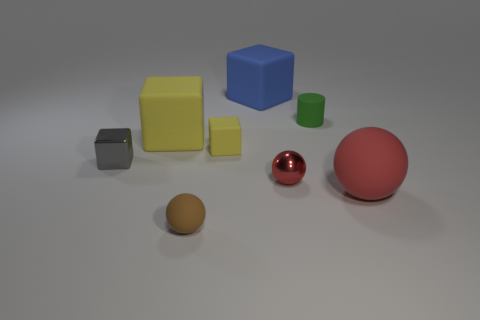Subtract 1 spheres. How many spheres are left? 2 Subtract all gray blocks. How many blocks are left? 3 Subtract all small gray cubes. How many cubes are left? 3 Subtract all cyan blocks. Subtract all red spheres. How many blocks are left? 4 Add 2 blue blocks. How many objects exist? 10 Subtract all cylinders. How many objects are left? 7 Add 3 small matte balls. How many small matte balls are left? 4 Add 2 small red shiny objects. How many small red shiny objects exist? 3 Subtract 1 blue cubes. How many objects are left? 7 Subtract all cubes. Subtract all small rubber objects. How many objects are left? 1 